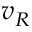<formula> <loc_0><loc_0><loc_500><loc_500>v _ { R }</formula> 